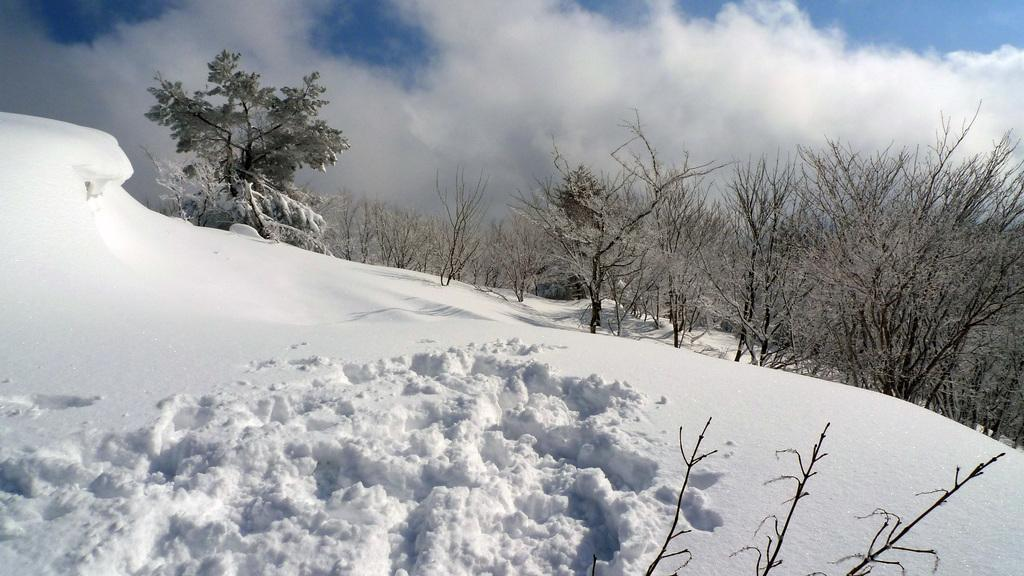What type of weather condition is depicted at the bottom of the image? There is snow at the bottom of the image. What type of natural environment can be seen in the background of the image? There are trees in the background of the image. What is visible at the top of the image? The sky is visible at the top of the image. What type of pollution can be seen in the image? There is no pollution visible in the image; it depicts a snowy scene with trees and sky. What type of dinner is being served in the image? There is no dinner or food present in the image. 